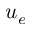<formula> <loc_0><loc_0><loc_500><loc_500>u _ { e }</formula> 